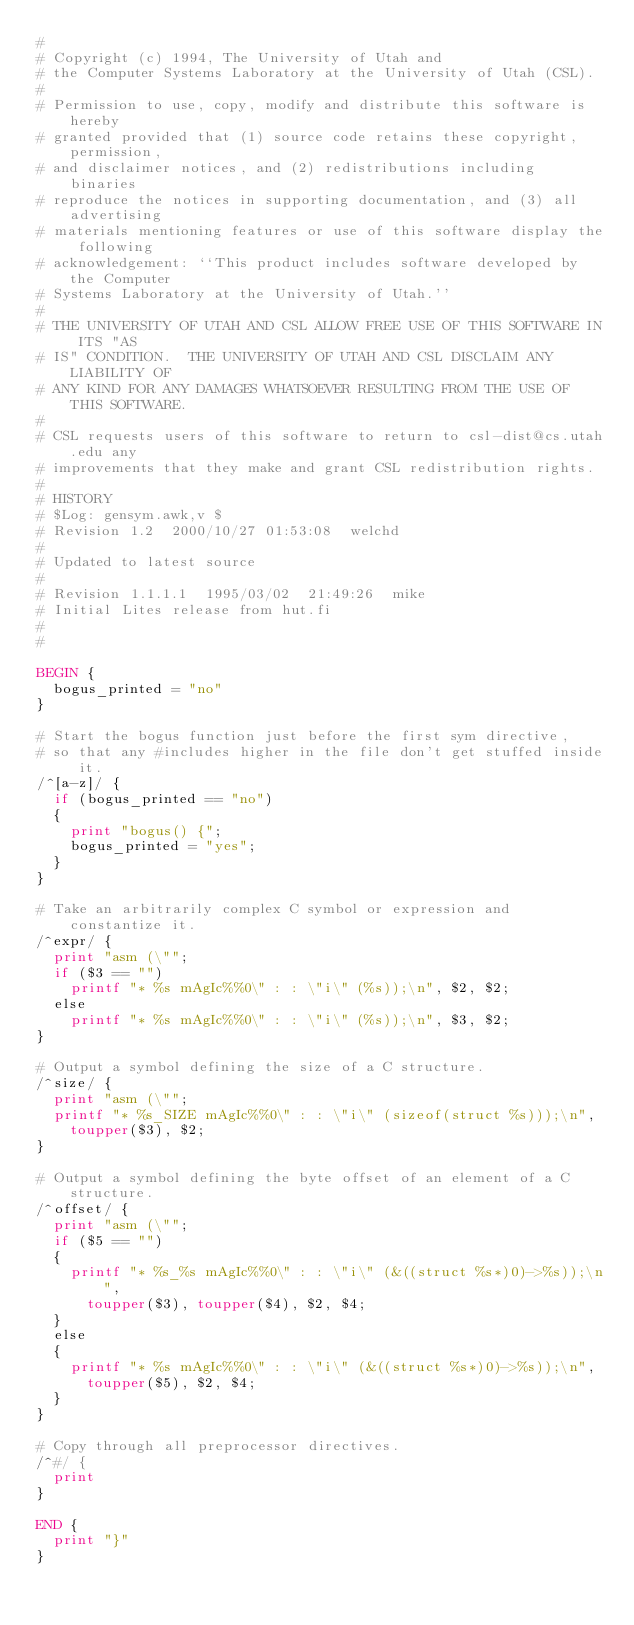Convert code to text. <code><loc_0><loc_0><loc_500><loc_500><_Awk_>#
# Copyright (c) 1994, The University of Utah and
# the Computer Systems Laboratory at the University of Utah (CSL).
#
# Permission to use, copy, modify and distribute this software is hereby
# granted provided that (1) source code retains these copyright, permission,
# and disclaimer notices, and (2) redistributions including binaries
# reproduce the notices in supporting documentation, and (3) all advertising
# materials mentioning features or use of this software display the following
# acknowledgement: ``This product includes software developed by the Computer
# Systems Laboratory at the University of Utah.''
#
# THE UNIVERSITY OF UTAH AND CSL ALLOW FREE USE OF THIS SOFTWARE IN ITS "AS
# IS" CONDITION.  THE UNIVERSITY OF UTAH AND CSL DISCLAIM ANY LIABILITY OF
# ANY KIND FOR ANY DAMAGES WHATSOEVER RESULTING FROM THE USE OF THIS SOFTWARE.
#
# CSL requests users of this software to return to csl-dist@cs.utah.edu any
# improvements that they make and grant CSL redistribution rights.
#
# HISTORY
# $Log: gensym.awk,v $
# Revision 1.2  2000/10/27 01:53:08  welchd
#
# Updated to latest source
#
# Revision 1.1.1.1  1995/03/02  21:49:26  mike
# Initial Lites release from hut.fi
#
#

BEGIN {
	bogus_printed = "no"
}

# Start the bogus function just before the first sym directive,
# so that any #includes higher in the file don't get stuffed inside it.
/^[a-z]/ {
	if (bogus_printed == "no")
	{
		print "bogus() {";
		bogus_printed = "yes";
	}
}

# Take an arbitrarily complex C symbol or expression and constantize it.
/^expr/ {
	print "asm (\"";
	if ($3 == "")
		printf "* %s mAgIc%%0\" : : \"i\" (%s));\n", $2, $2;
	else
		printf "* %s mAgIc%%0\" : : \"i\" (%s));\n", $3, $2;
}

# Output a symbol defining the size of a C structure.
/^size/ {
	print "asm (\"";
	printf "* %s_SIZE mAgIc%%0\" : : \"i\" (sizeof(struct %s)));\n",
		toupper($3), $2;
}

# Output a symbol defining the byte offset of an element of a C structure.
/^offset/ {
	print "asm (\"";
	if ($5 == "")
	{
		printf "* %s_%s mAgIc%%0\" : : \"i\" (&((struct %s*)0)->%s));\n",
			toupper($3), toupper($4), $2, $4;
	}
	else
	{
		printf "* %s mAgIc%%0\" : : \"i\" (&((struct %s*)0)->%s));\n",
			toupper($5), $2, $4;
	}
}

# Copy through all preprocessor directives.
/^#/ {
	print
}

END {
	print "}"
}

</code> 